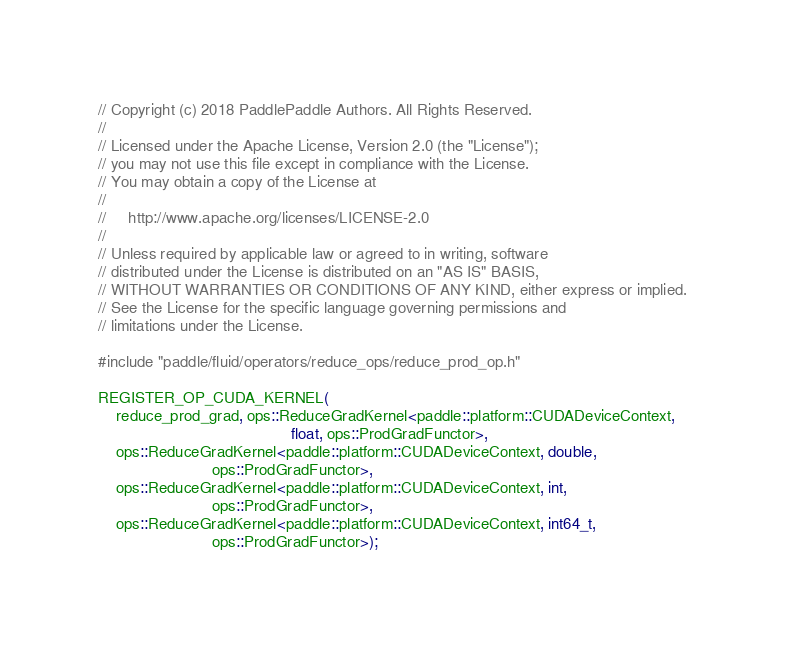<code> <loc_0><loc_0><loc_500><loc_500><_Cuda_>// Copyright (c) 2018 PaddlePaddle Authors. All Rights Reserved.
//
// Licensed under the Apache License, Version 2.0 (the "License");
// you may not use this file except in compliance with the License.
// You may obtain a copy of the License at
//
//     http://www.apache.org/licenses/LICENSE-2.0
//
// Unless required by applicable law or agreed to in writing, software
// distributed under the License is distributed on an "AS IS" BASIS,
// WITHOUT WARRANTIES OR CONDITIONS OF ANY KIND, either express or implied.
// See the License for the specific language governing permissions and
// limitations under the License.

#include "paddle/fluid/operators/reduce_ops/reduce_prod_op.h"

REGISTER_OP_CUDA_KERNEL(
    reduce_prod_grad, ops::ReduceGradKernel<paddle::platform::CUDADeviceContext,
                                            float, ops::ProdGradFunctor>,
    ops::ReduceGradKernel<paddle::platform::CUDADeviceContext, double,
                          ops::ProdGradFunctor>,
    ops::ReduceGradKernel<paddle::platform::CUDADeviceContext, int,
                          ops::ProdGradFunctor>,
    ops::ReduceGradKernel<paddle::platform::CUDADeviceContext, int64_t,
                          ops::ProdGradFunctor>);
</code> 